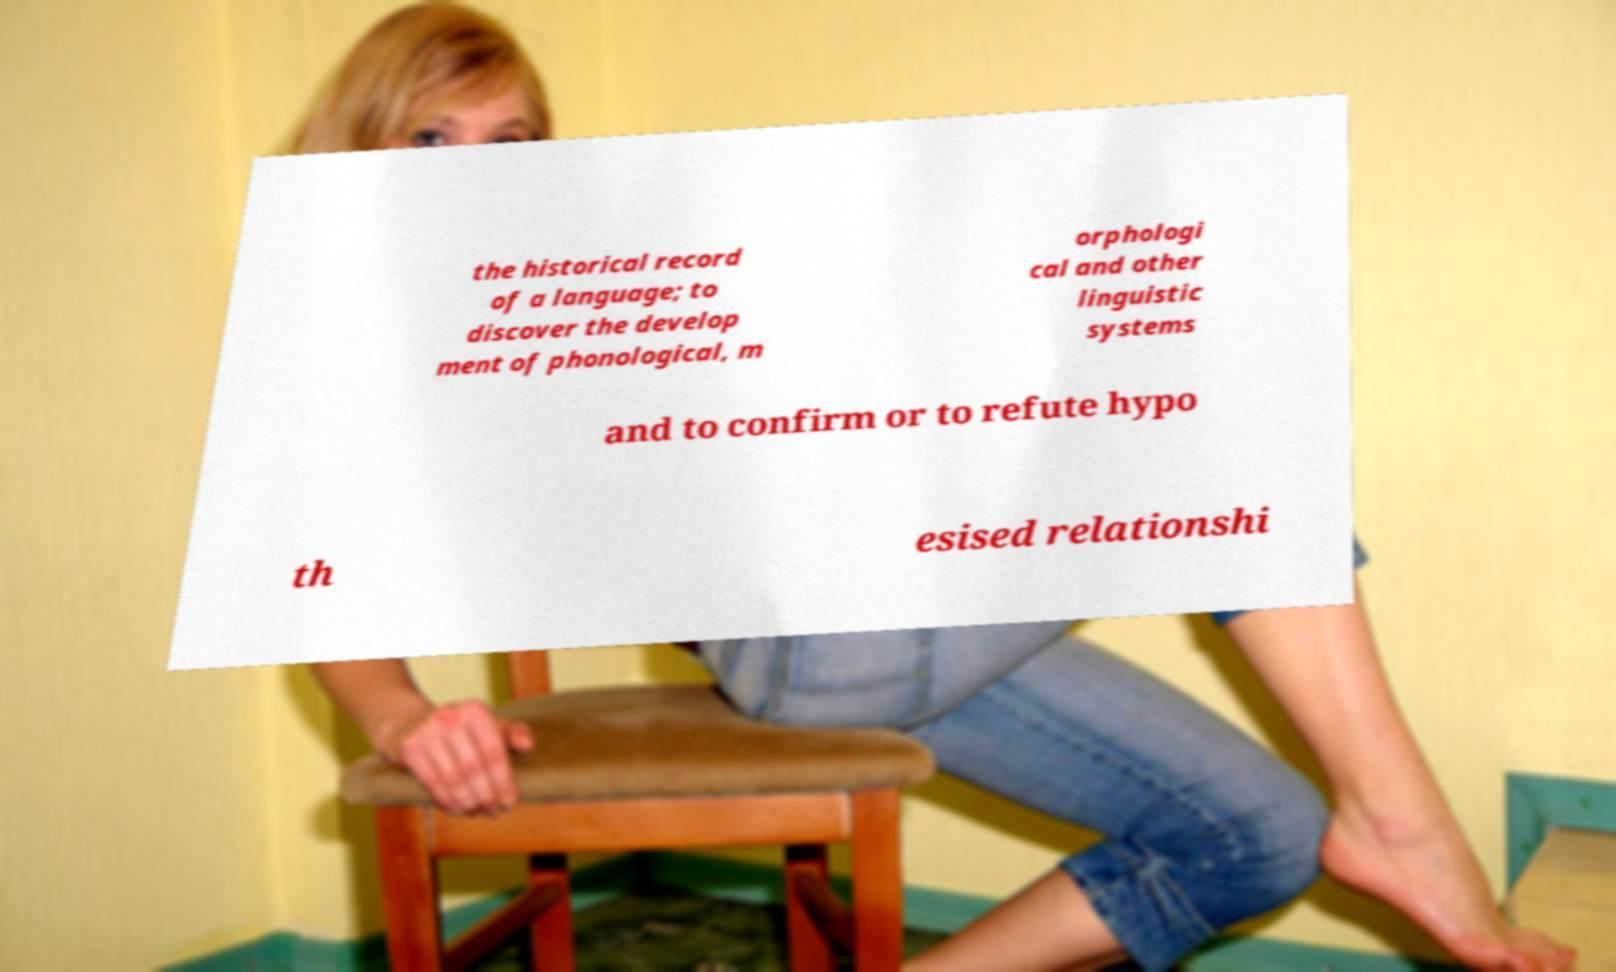Please read and relay the text visible in this image. What does it say? the historical record of a language; to discover the develop ment of phonological, m orphologi cal and other linguistic systems and to confirm or to refute hypo th esised relationshi 